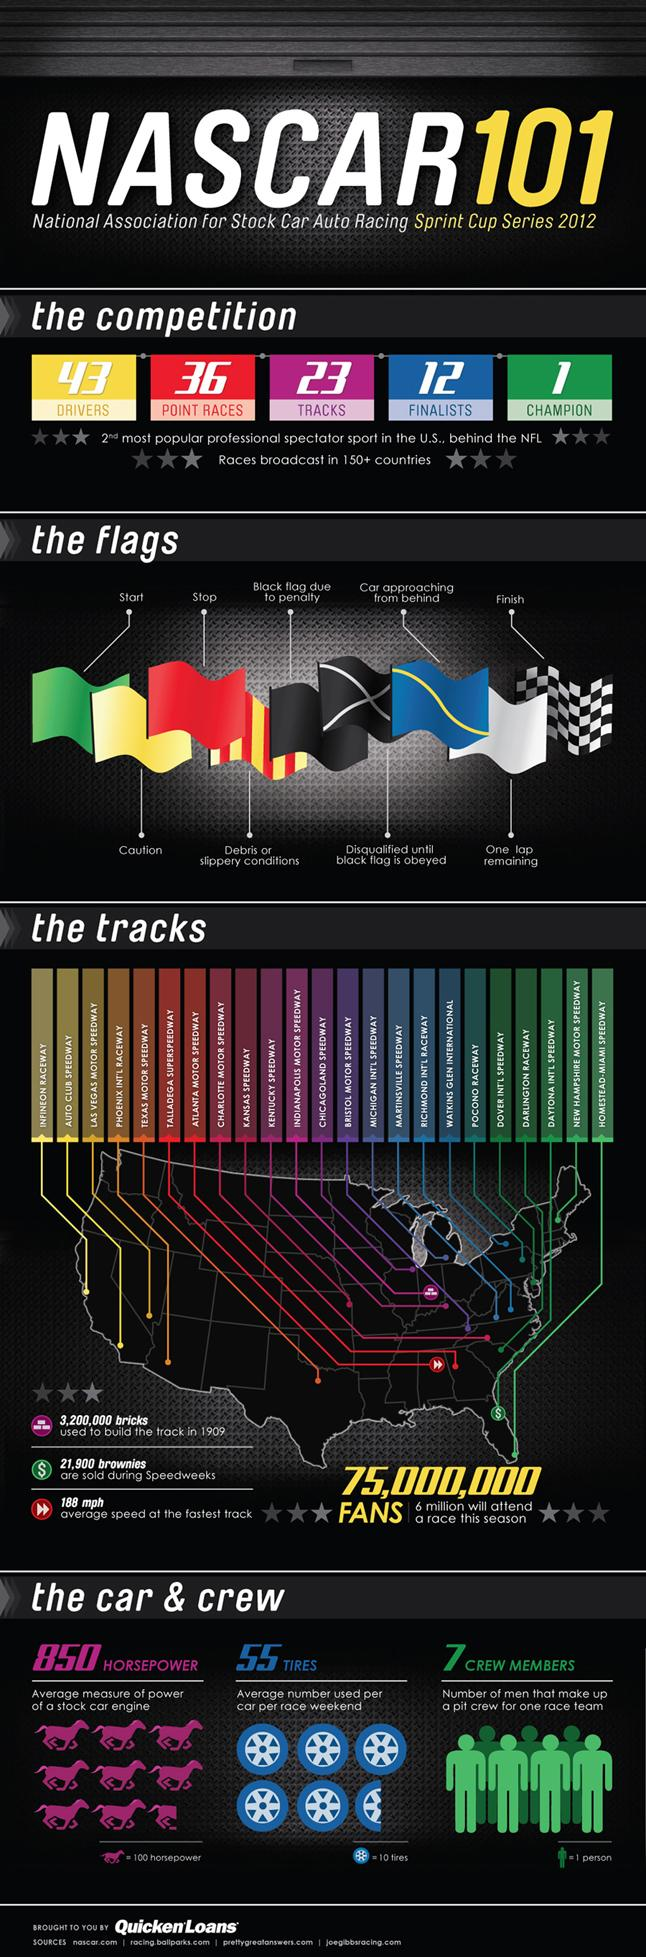Identify some key points in this picture. The National Football League (NFL) is the most popular professional spectator sport in the United States. There are 12 finalists. There were 9 flags used in the championship. There will be 36 point races. 